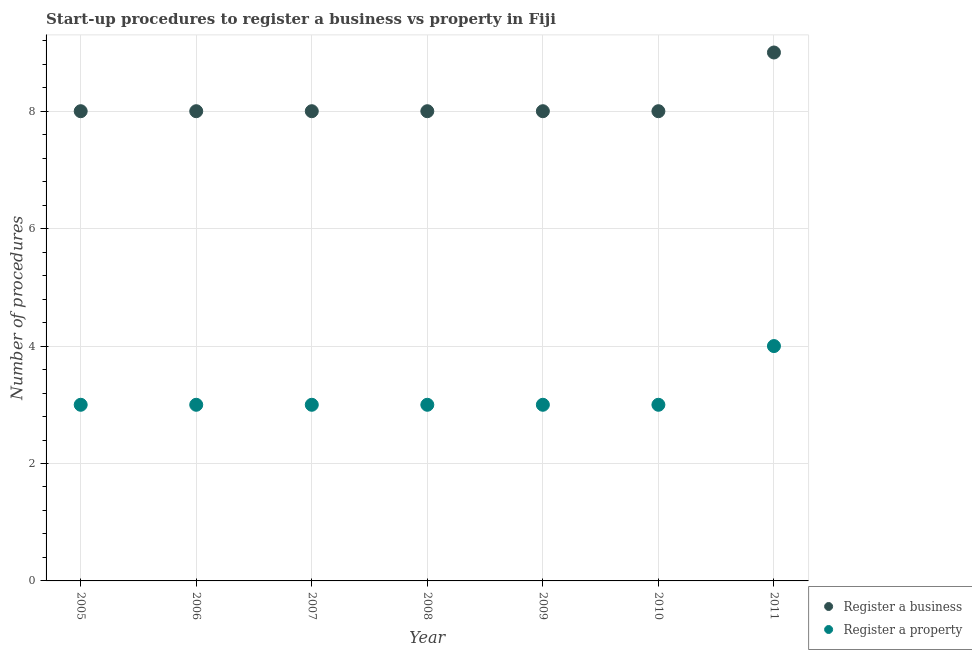How many different coloured dotlines are there?
Your answer should be very brief. 2. What is the number of procedures to register a property in 2011?
Provide a succinct answer. 4. Across all years, what is the maximum number of procedures to register a property?
Keep it short and to the point. 4. Across all years, what is the minimum number of procedures to register a business?
Give a very brief answer. 8. What is the total number of procedures to register a property in the graph?
Offer a very short reply. 22. What is the difference between the number of procedures to register a business in 2005 and the number of procedures to register a property in 2009?
Your answer should be very brief. 5. What is the average number of procedures to register a business per year?
Your answer should be compact. 8.14. In the year 2010, what is the difference between the number of procedures to register a business and number of procedures to register a property?
Provide a succinct answer. 5. What is the difference between the highest and the second highest number of procedures to register a property?
Offer a terse response. 1. What is the difference between the highest and the lowest number of procedures to register a property?
Your response must be concise. 1. In how many years, is the number of procedures to register a business greater than the average number of procedures to register a business taken over all years?
Your answer should be compact. 1. Is the sum of the number of procedures to register a property in 2006 and 2008 greater than the maximum number of procedures to register a business across all years?
Provide a short and direct response. No. Is the number of procedures to register a property strictly less than the number of procedures to register a business over the years?
Give a very brief answer. Yes. How many dotlines are there?
Provide a short and direct response. 2. Are the values on the major ticks of Y-axis written in scientific E-notation?
Your answer should be very brief. No. Does the graph contain grids?
Make the answer very short. Yes. How are the legend labels stacked?
Make the answer very short. Vertical. What is the title of the graph?
Provide a succinct answer. Start-up procedures to register a business vs property in Fiji. What is the label or title of the X-axis?
Ensure brevity in your answer.  Year. What is the label or title of the Y-axis?
Provide a succinct answer. Number of procedures. What is the Number of procedures in Register a property in 2005?
Your answer should be compact. 3. What is the Number of procedures in Register a business in 2006?
Give a very brief answer. 8. What is the Number of procedures in Register a business in 2007?
Keep it short and to the point. 8. What is the Number of procedures in Register a business in 2008?
Your answer should be very brief. 8. What is the Number of procedures of Register a business in 2009?
Your answer should be compact. 8. What is the Number of procedures of Register a property in 2009?
Keep it short and to the point. 3. What is the Number of procedures of Register a business in 2011?
Offer a very short reply. 9. What is the Number of procedures in Register a property in 2011?
Your answer should be compact. 4. Across all years, what is the maximum Number of procedures in Register a property?
Ensure brevity in your answer.  4. Across all years, what is the minimum Number of procedures in Register a business?
Offer a very short reply. 8. Across all years, what is the minimum Number of procedures of Register a property?
Offer a very short reply. 3. What is the total Number of procedures of Register a property in the graph?
Provide a succinct answer. 22. What is the difference between the Number of procedures in Register a business in 2005 and that in 2006?
Your answer should be compact. 0. What is the difference between the Number of procedures in Register a property in 2005 and that in 2008?
Give a very brief answer. 0. What is the difference between the Number of procedures in Register a business in 2005 and that in 2009?
Keep it short and to the point. 0. What is the difference between the Number of procedures in Register a property in 2005 and that in 2009?
Your answer should be compact. 0. What is the difference between the Number of procedures of Register a business in 2005 and that in 2010?
Provide a succinct answer. 0. What is the difference between the Number of procedures of Register a property in 2005 and that in 2011?
Offer a very short reply. -1. What is the difference between the Number of procedures in Register a business in 2006 and that in 2007?
Make the answer very short. 0. What is the difference between the Number of procedures in Register a business in 2006 and that in 2008?
Provide a succinct answer. 0. What is the difference between the Number of procedures in Register a property in 2006 and that in 2008?
Provide a short and direct response. 0. What is the difference between the Number of procedures in Register a property in 2006 and that in 2009?
Provide a short and direct response. 0. What is the difference between the Number of procedures in Register a business in 2006 and that in 2010?
Your answer should be very brief. 0. What is the difference between the Number of procedures of Register a business in 2006 and that in 2011?
Offer a terse response. -1. What is the difference between the Number of procedures of Register a business in 2007 and that in 2009?
Provide a succinct answer. 0. What is the difference between the Number of procedures of Register a business in 2007 and that in 2011?
Offer a very short reply. -1. What is the difference between the Number of procedures of Register a property in 2007 and that in 2011?
Provide a short and direct response. -1. What is the difference between the Number of procedures in Register a business in 2008 and that in 2009?
Your answer should be very brief. 0. What is the difference between the Number of procedures of Register a property in 2008 and that in 2009?
Your answer should be compact. 0. What is the difference between the Number of procedures in Register a property in 2008 and that in 2011?
Your answer should be very brief. -1. What is the difference between the Number of procedures in Register a business in 2009 and that in 2010?
Your response must be concise. 0. What is the difference between the Number of procedures in Register a business in 2009 and that in 2011?
Make the answer very short. -1. What is the difference between the Number of procedures in Register a business in 2005 and the Number of procedures in Register a property in 2007?
Your answer should be very brief. 5. What is the difference between the Number of procedures of Register a business in 2006 and the Number of procedures of Register a property in 2008?
Offer a terse response. 5. What is the difference between the Number of procedures in Register a business in 2006 and the Number of procedures in Register a property in 2009?
Ensure brevity in your answer.  5. What is the difference between the Number of procedures in Register a business in 2006 and the Number of procedures in Register a property in 2010?
Your answer should be compact. 5. What is the difference between the Number of procedures of Register a business in 2007 and the Number of procedures of Register a property in 2011?
Offer a very short reply. 4. What is the difference between the Number of procedures of Register a business in 2008 and the Number of procedures of Register a property in 2009?
Offer a very short reply. 5. What is the difference between the Number of procedures of Register a business in 2008 and the Number of procedures of Register a property in 2010?
Offer a very short reply. 5. What is the difference between the Number of procedures in Register a business in 2008 and the Number of procedures in Register a property in 2011?
Keep it short and to the point. 4. What is the difference between the Number of procedures in Register a business in 2010 and the Number of procedures in Register a property in 2011?
Provide a short and direct response. 4. What is the average Number of procedures of Register a business per year?
Ensure brevity in your answer.  8.14. What is the average Number of procedures of Register a property per year?
Offer a terse response. 3.14. In the year 2005, what is the difference between the Number of procedures of Register a business and Number of procedures of Register a property?
Provide a short and direct response. 5. In the year 2006, what is the difference between the Number of procedures in Register a business and Number of procedures in Register a property?
Offer a terse response. 5. In the year 2007, what is the difference between the Number of procedures of Register a business and Number of procedures of Register a property?
Make the answer very short. 5. In the year 2010, what is the difference between the Number of procedures of Register a business and Number of procedures of Register a property?
Give a very brief answer. 5. What is the ratio of the Number of procedures of Register a property in 2005 to that in 2006?
Make the answer very short. 1. What is the ratio of the Number of procedures of Register a business in 2005 to that in 2007?
Your answer should be compact. 1. What is the ratio of the Number of procedures of Register a business in 2005 to that in 2008?
Provide a short and direct response. 1. What is the ratio of the Number of procedures in Register a property in 2005 to that in 2009?
Make the answer very short. 1. What is the ratio of the Number of procedures of Register a property in 2005 to that in 2010?
Provide a succinct answer. 1. What is the ratio of the Number of procedures of Register a business in 2005 to that in 2011?
Offer a terse response. 0.89. What is the ratio of the Number of procedures in Register a business in 2006 to that in 2007?
Ensure brevity in your answer.  1. What is the ratio of the Number of procedures of Register a business in 2006 to that in 2010?
Give a very brief answer. 1. What is the ratio of the Number of procedures of Register a property in 2006 to that in 2010?
Keep it short and to the point. 1. What is the ratio of the Number of procedures in Register a business in 2006 to that in 2011?
Give a very brief answer. 0.89. What is the ratio of the Number of procedures in Register a property in 2006 to that in 2011?
Offer a terse response. 0.75. What is the ratio of the Number of procedures of Register a business in 2007 to that in 2008?
Ensure brevity in your answer.  1. What is the ratio of the Number of procedures in Register a property in 2007 to that in 2008?
Ensure brevity in your answer.  1. What is the ratio of the Number of procedures in Register a business in 2007 to that in 2010?
Your answer should be very brief. 1. What is the ratio of the Number of procedures of Register a property in 2007 to that in 2010?
Offer a very short reply. 1. What is the ratio of the Number of procedures in Register a business in 2007 to that in 2011?
Offer a terse response. 0.89. What is the ratio of the Number of procedures of Register a property in 2007 to that in 2011?
Make the answer very short. 0.75. What is the ratio of the Number of procedures of Register a property in 2008 to that in 2010?
Give a very brief answer. 1. What is the ratio of the Number of procedures in Register a business in 2008 to that in 2011?
Give a very brief answer. 0.89. What is the ratio of the Number of procedures of Register a property in 2008 to that in 2011?
Make the answer very short. 0.75. What is the ratio of the Number of procedures of Register a business in 2010 to that in 2011?
Provide a succinct answer. 0.89. What is the ratio of the Number of procedures in Register a property in 2010 to that in 2011?
Make the answer very short. 0.75. What is the difference between the highest and the lowest Number of procedures in Register a property?
Your answer should be compact. 1. 